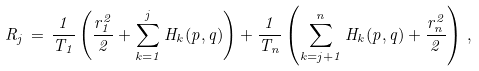<formula> <loc_0><loc_0><loc_500><loc_500>R _ { j } \, = \, \frac { 1 } { T _ { 1 } } \left ( \frac { r _ { 1 } ^ { 2 } } { 2 } + \sum _ { k = 1 } ^ { j } H _ { k } ( p , q ) \right ) + \frac { 1 } { T _ { n } } \left ( \sum _ { k = j + 1 } ^ { n } H _ { k } ( p , q ) + \frac { r _ { n } ^ { 2 } } { 2 } \right ) \, ,</formula> 